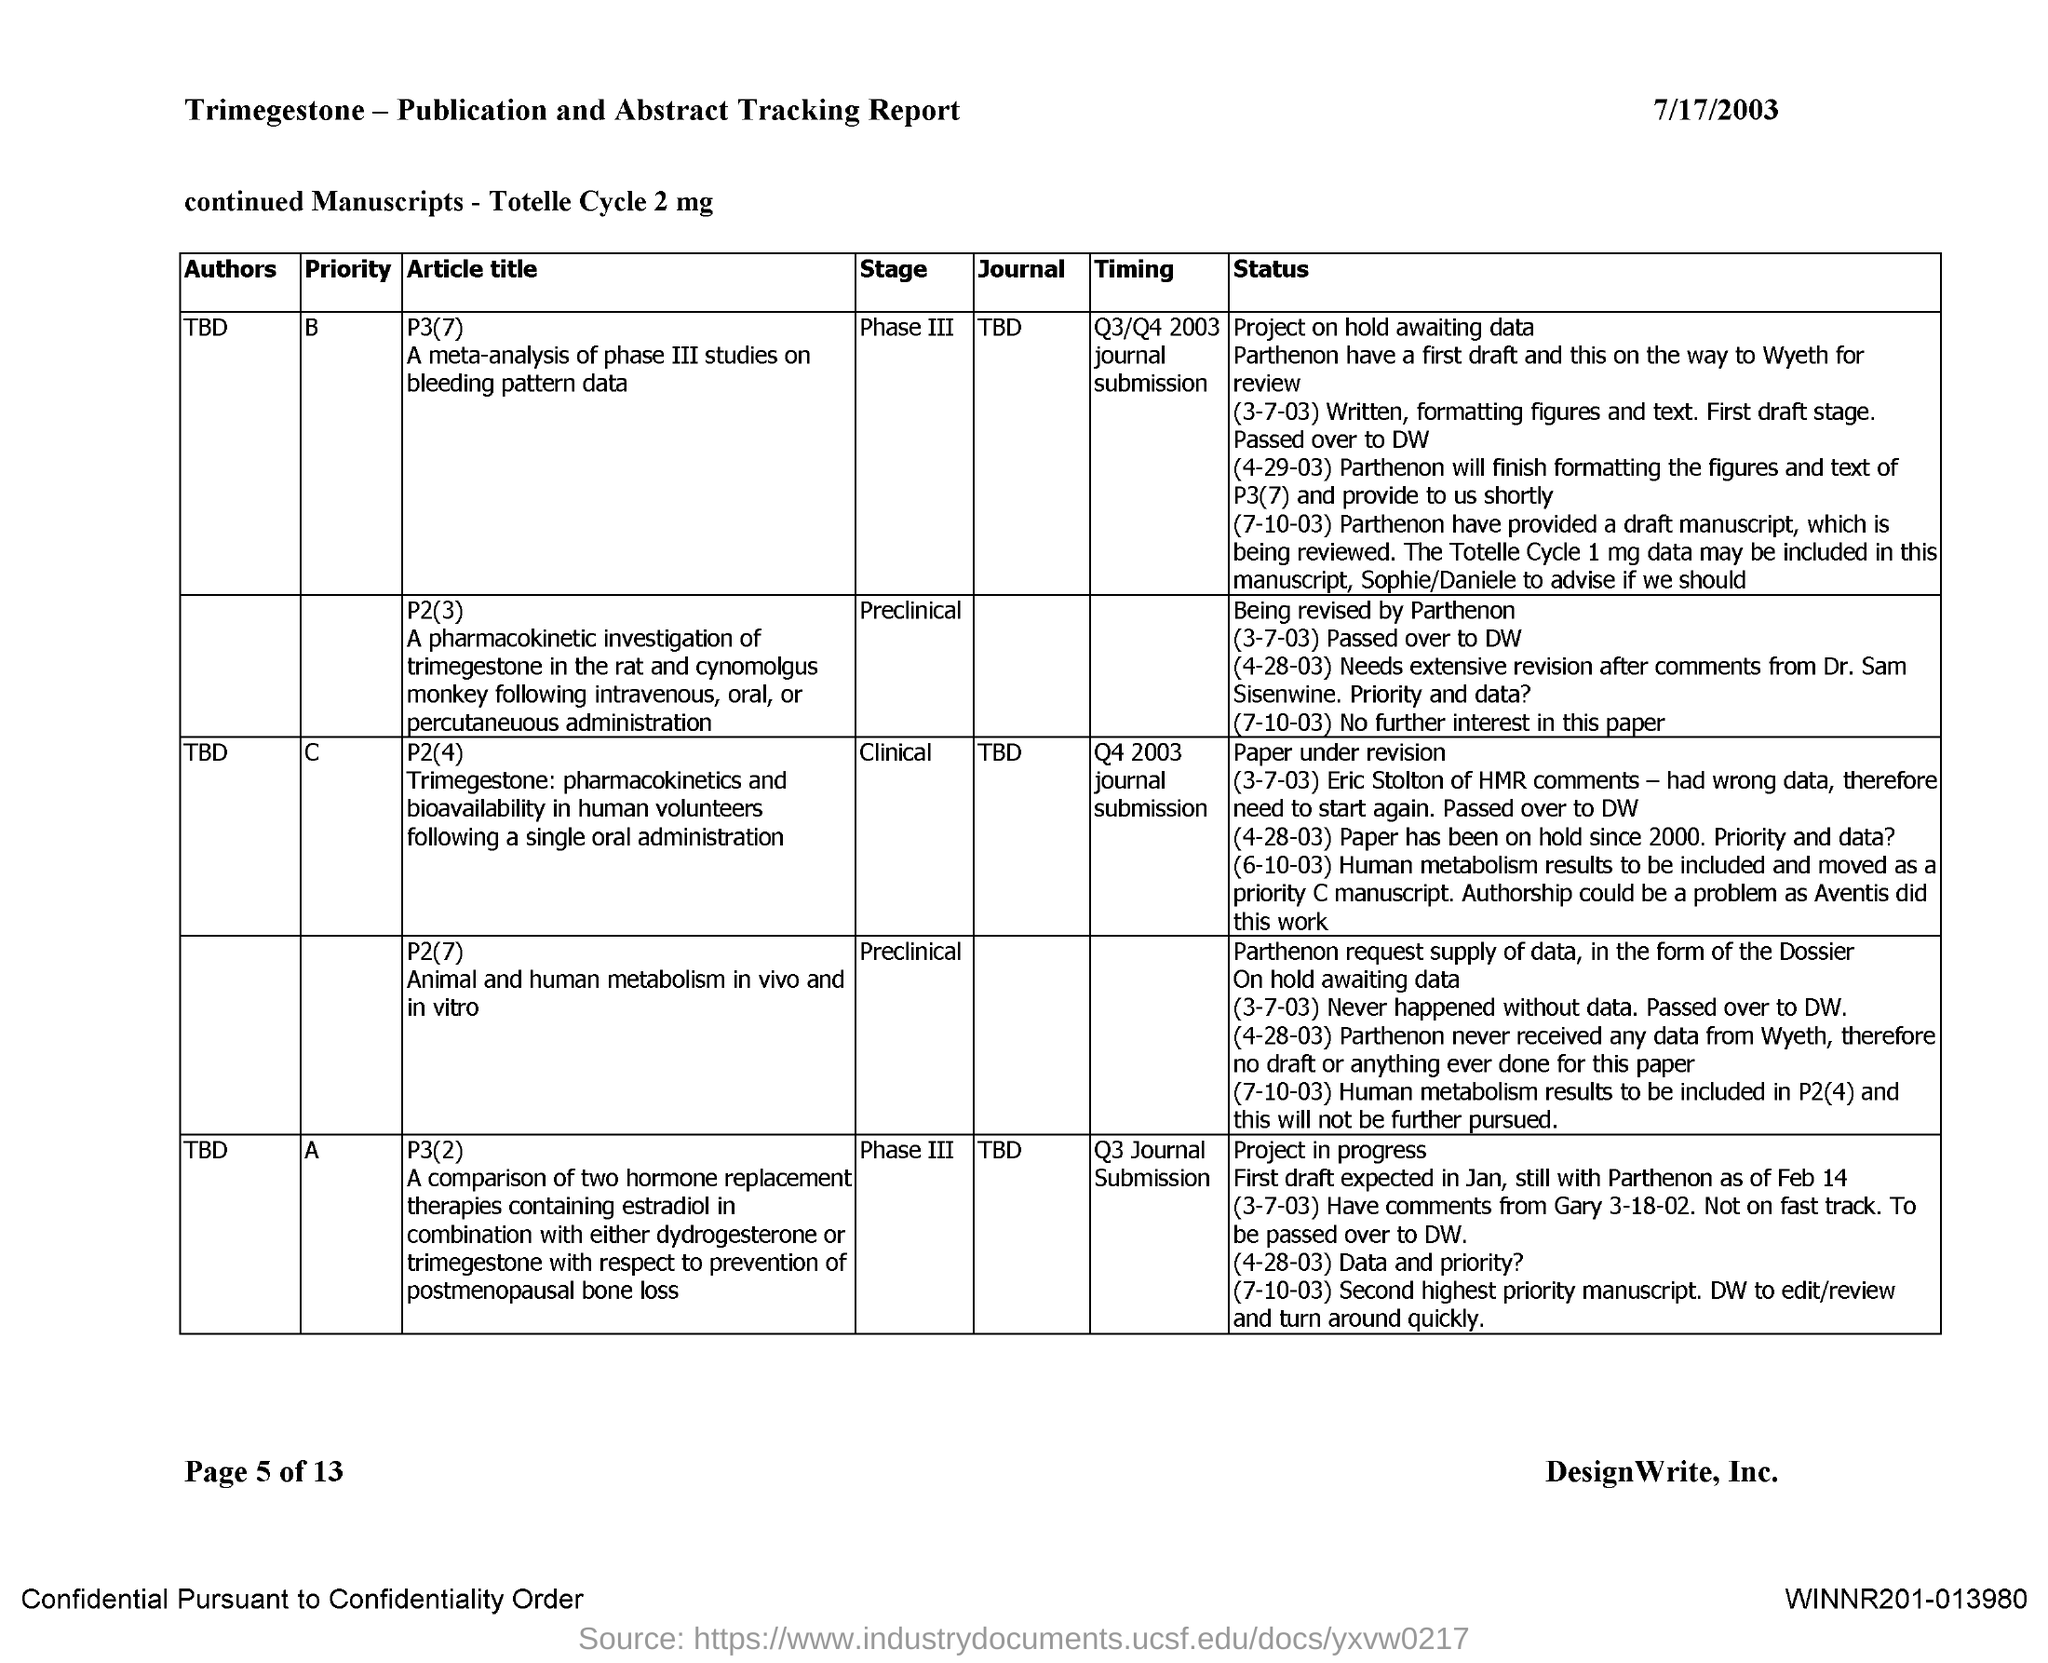Outline some significant characteristics in this image. The exact meaning of the phrase "Who is the author of the journal TBD with priority 'A'?" is unclear without more context. Here is one possible interpretation:

"Who is the person or entity responsible for writing or publishing the journal TBD with a priority level of 'A'? The author of the journal with priority 'B' is TBD. The journal TBD with priority "C" has not yet been assigned to an author. The name of the journal with priority level B is currently TBD (to be determined). The date mentioned in the document is July 17, 2003. 